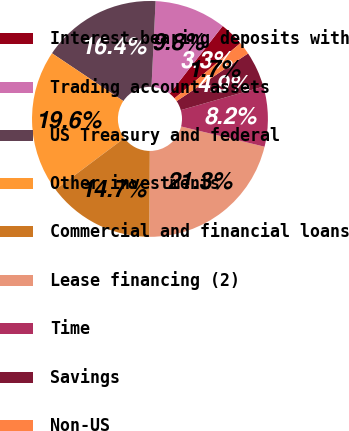<chart> <loc_0><loc_0><loc_500><loc_500><pie_chart><fcel>Interest-bearing deposits with<fcel>Trading account assets<fcel>US Treasury and federal<fcel>Other investments<fcel>Commercial and financial loans<fcel>Lease financing (2)<fcel>Time<fcel>Savings<fcel>Non-US<nl><fcel>3.34%<fcel>9.81%<fcel>16.37%<fcel>19.62%<fcel>14.72%<fcel>21.27%<fcel>8.2%<fcel>4.95%<fcel>1.73%<nl></chart> 